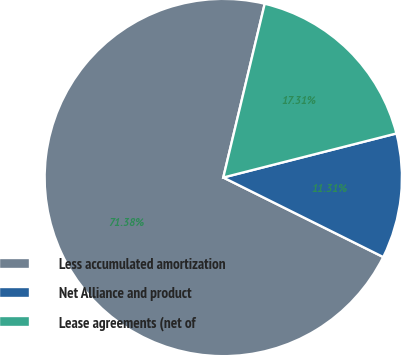Convert chart. <chart><loc_0><loc_0><loc_500><loc_500><pie_chart><fcel>Less accumulated amortization<fcel>Net Alliance and product<fcel>Lease agreements (net of<nl><fcel>71.38%<fcel>11.31%<fcel>17.31%<nl></chart> 